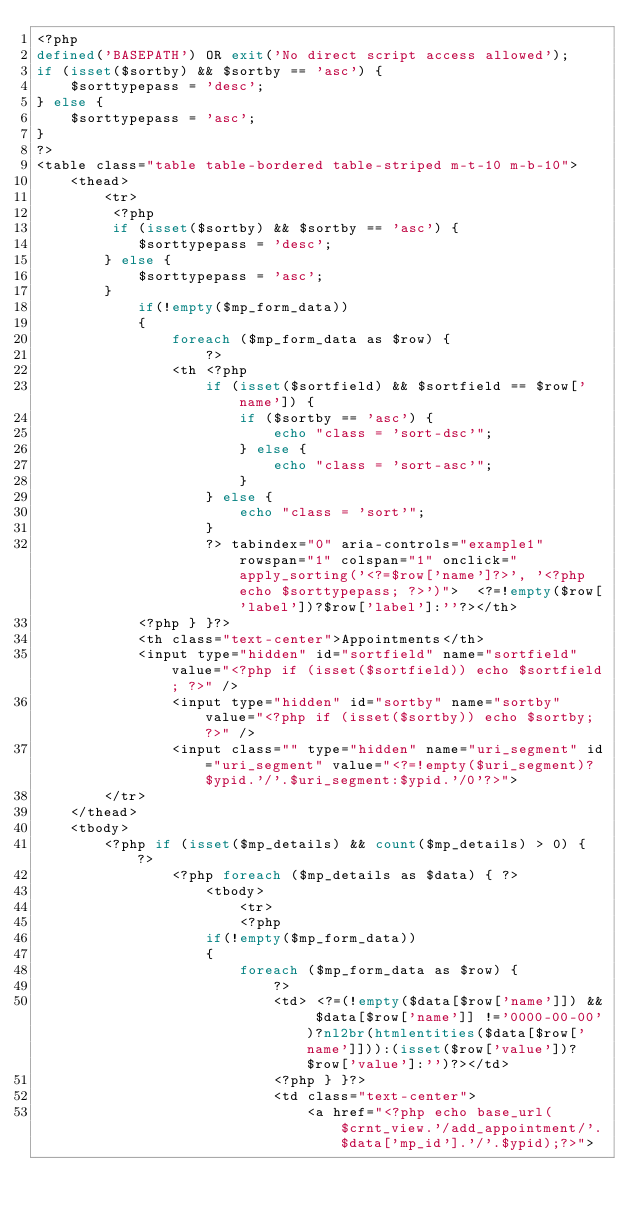Convert code to text. <code><loc_0><loc_0><loc_500><loc_500><_PHP_><?php
defined('BASEPATH') OR exit('No direct script access allowed');
if (isset($sortby) && $sortby == 'asc') {
    $sorttypepass = 'desc';
} else {
    $sorttypepass = 'asc';
}
?>
<table class="table table-bordered table-striped m-t-10 m-b-10">
    <thead>
        <tr>
         <?php
         if (isset($sortby) && $sortby == 'asc') {
            $sorttypepass = 'desc';
        } else {
            $sorttypepass = 'asc';
        }
            if(!empty($mp_form_data))
            {
                foreach ($mp_form_data as $row) {
                    ?>
                <th <?php
                    if (isset($sortfield) && $sortfield == $row['name']) {
                        if ($sortby == 'asc') {
                            echo "class = 'sort-dsc'";
                        } else {
                            echo "class = 'sort-asc'";
                        }
                    } else {
                        echo "class = 'sort'";
                    }
                    ?> tabindex="0" aria-controls="example1" rowspan="1" colspan="1" onclick="apply_sorting('<?=$row['name']?>', '<?php echo $sorttypepass; ?>')">  <?=!empty($row['label'])?$row['label']:''?></th>
            <?php } }?>
            <th class="text-center">Appointments</th>
            <input type="hidden" id="sortfield" name="sortfield" value="<?php if (isset($sortfield)) echo $sortfield; ?>" />
                <input type="hidden" id="sortby" name="sortby" value="<?php if (isset($sortby)) echo $sortby; ?>" /> 
                <input class="" type="hidden" name="uri_segment" id="uri_segment" value="<?=!empty($uri_segment)?$ypid.'/'.$uri_segment:$ypid.'/0'?>">  
        </tr>
    </thead>
    <tbody>
        <?php if (isset($mp_details) && count($mp_details) > 0) { ?>
                <?php foreach ($mp_details as $data) { ?>
                    <tbody>
                        <tr>
                        <?php
                    if(!empty($mp_form_data))
                    {
                        foreach ($mp_form_data as $row) {
                            ?>
                            <td> <?=(!empty($data[$row['name']]) && $data[$row['name']] !='0000-00-00')?nl2br(htmlentities($data[$row['name']])):(isset($row['value'])?$row['value']:'')?></td>
                            <?php } }?>
                            <td class="text-center">
                                <a href="<?php echo base_url($crnt_view.'/add_appointment/'.$data['mp_id'].'/'.$ypid);?>"></code> 